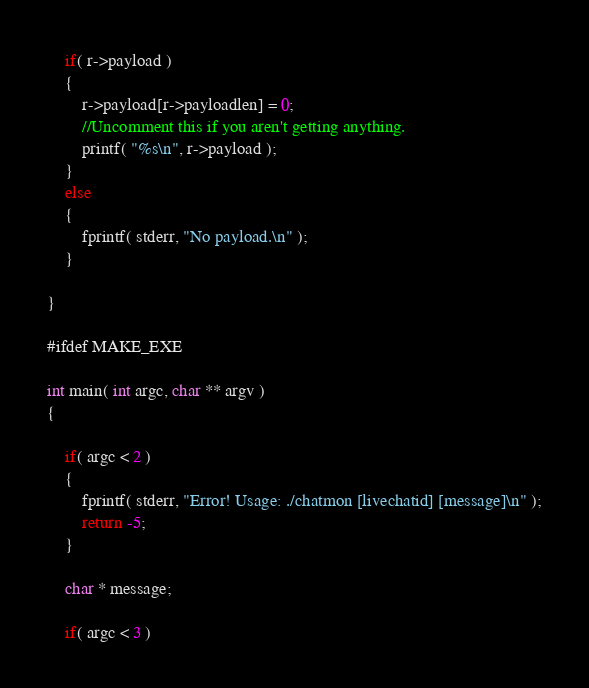Convert code to text. <code><loc_0><loc_0><loc_500><loc_500><_C_>	if( r->payload )
	{
		r->payload[r->payloadlen] = 0;
		//Uncomment this if you aren't getting anything.
		printf( "%s\n", r->payload );
	}
	else
	{
		fprintf( stderr, "No payload.\n" );
	}

}

#ifdef MAKE_EXE

int main( int argc, char ** argv )
{

	if( argc < 2 )
	{
		fprintf( stderr, "Error! Usage: ./chatmon [livechatid] [message]\n" );
		return -5;
	}

	char * message;

	if( argc < 3 )</code> 